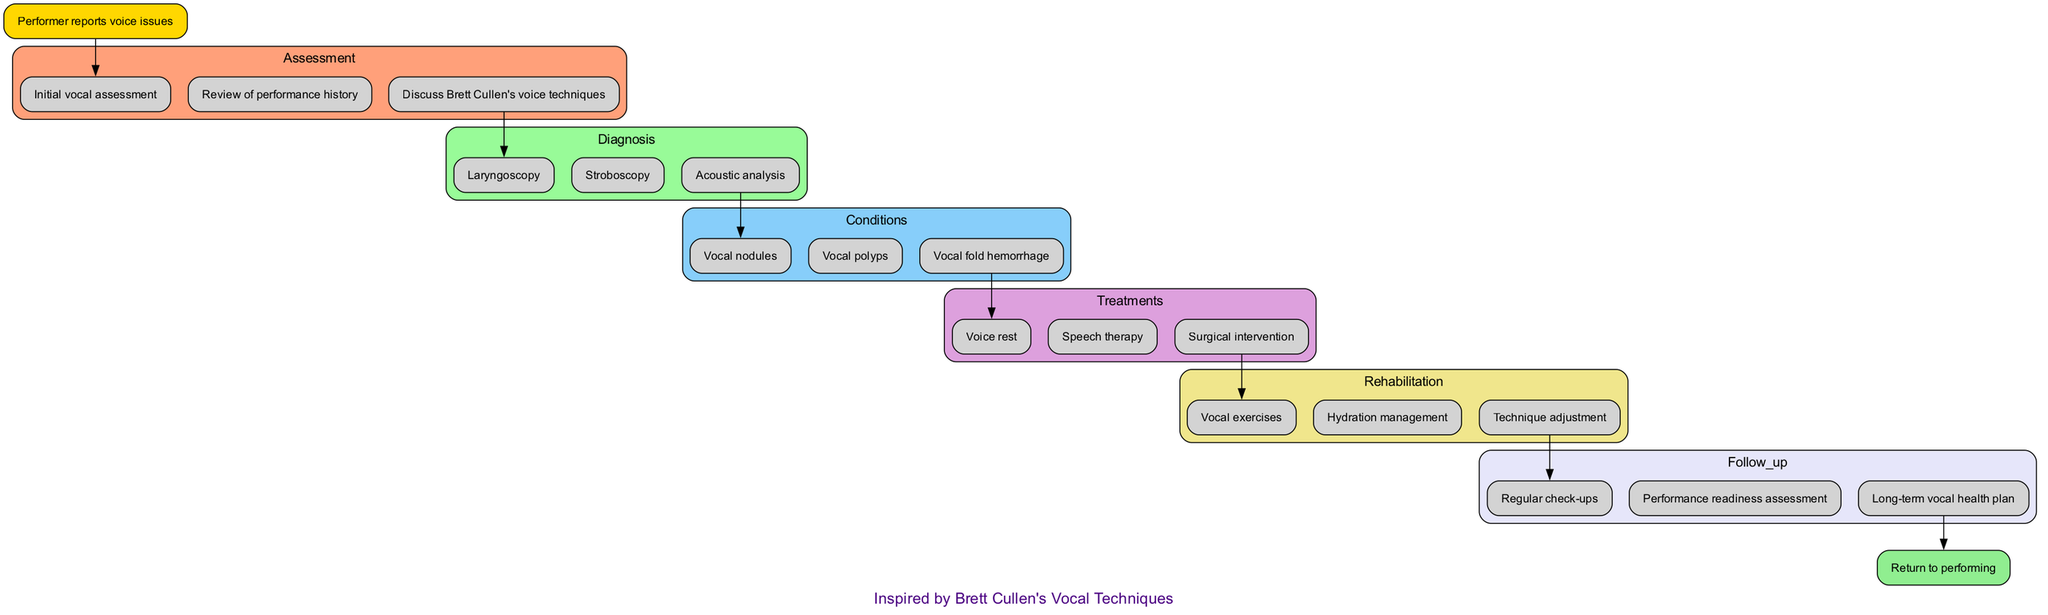What is the first step when a performer reports voice issues? The diagram indicates that the first step is "Initial vocal assessment," which is the first node connected directly to the "Performer reports voice issues" start node.
Answer: Initial vocal assessment How many treatments are listed in the pathway? By counting the nodes under the "treatments" stage in the diagram, there are three treatments: "Voice rest," "Speech therapy," and "Surgical intervention."
Answer: 3 What condition follows the diagnosis step? The diagram shows that after the "diagnosis" step, the next stage is "conditions," which includes various conditions such as "Vocal nodules," "Vocal polyps," and "Vocal fold hemorrhage."
Answer: Vocal nodules What does the rehabilitation phase include? In the diagram, the "rehabilitation" phase includes "Vocal exercises," "Hydration management," and "Technique adjustment" and consists of three elements.
Answer: Vocal exercises What is the relationship between the treatments and conditions stages? The treatments stage directly follows the conditions stage in the flow of the diagram, meaning that conditions must be identified before appropriate treatments can be applied.
Answer: Treatments follow conditions How many assessment steps are there before diagnosis? The assessment stage lists three steps, which are "Initial vocal assessment," "Review of performance history," and "Discuss Brett Cullen's voice techniques." There are three distinct assessment steps.
Answer: 3 What is the final step in the clinical pathway? The end node in the diagram is labeled "Return to performing," indicating the final outcome of the clinical pathway after following all previous steps.
Answer: Return to performing Which assessment step focuses on Brett Cullen? The assessment step that discusses Brett Cullen’s techniques is labeled "Discuss Brett Cullen's voice techniques," showing a direct connection to his vocal methods.
Answer: Discuss Brett Cullen's voice techniques What is the purpose of the follow-up phase? The follow-up phase aims to conduct "Regular check-ups," "Performance readiness assessment," and "Long-term vocal health plan," which collectively ensure continuous health monitoring.
Answer: Regular check-ups 